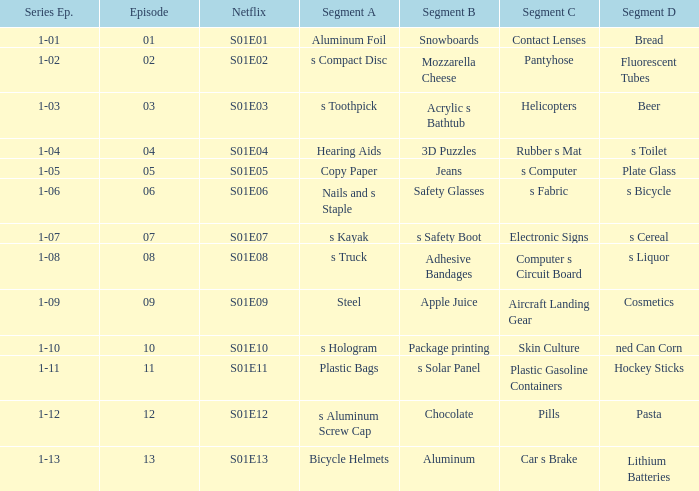What is the label for segment a, which has a netflix reference of s01e12? S aluminum screw cap. 